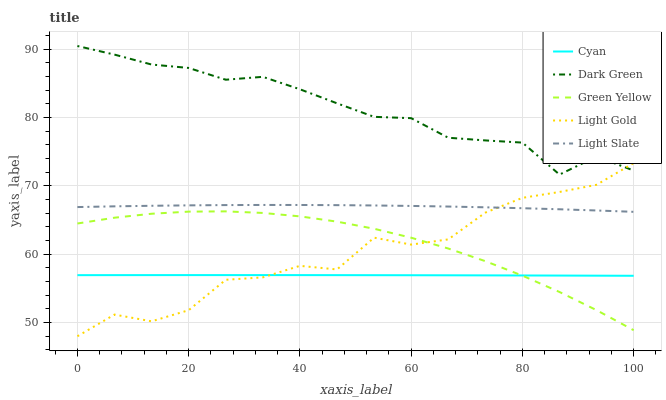Does Cyan have the minimum area under the curve?
Answer yes or no. Yes. Does Dark Green have the maximum area under the curve?
Answer yes or no. Yes. Does Green Yellow have the minimum area under the curve?
Answer yes or no. No. Does Green Yellow have the maximum area under the curve?
Answer yes or no. No. Is Cyan the smoothest?
Answer yes or no. Yes. Is Light Gold the roughest?
Answer yes or no. Yes. Is Green Yellow the smoothest?
Answer yes or no. No. Is Green Yellow the roughest?
Answer yes or no. No. Does Light Gold have the lowest value?
Answer yes or no. Yes. Does Cyan have the lowest value?
Answer yes or no. No. Does Dark Green have the highest value?
Answer yes or no. Yes. Does Green Yellow have the highest value?
Answer yes or no. No. Is Green Yellow less than Light Slate?
Answer yes or no. Yes. Is Light Slate greater than Cyan?
Answer yes or no. Yes. Does Light Gold intersect Light Slate?
Answer yes or no. Yes. Is Light Gold less than Light Slate?
Answer yes or no. No. Is Light Gold greater than Light Slate?
Answer yes or no. No. Does Green Yellow intersect Light Slate?
Answer yes or no. No. 